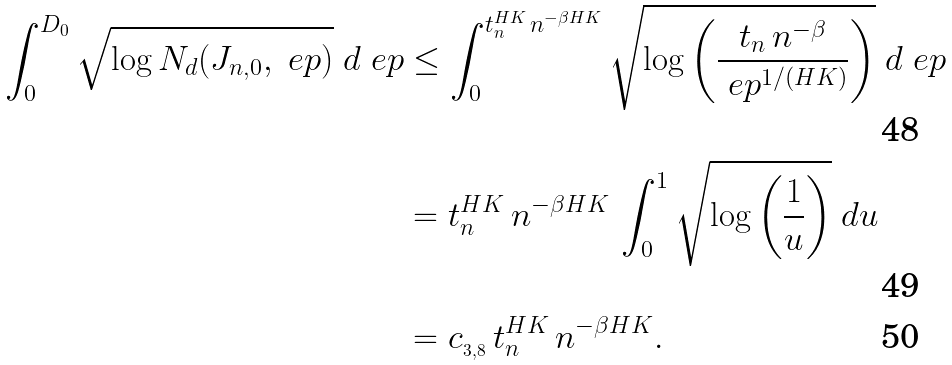Convert formula to latex. <formula><loc_0><loc_0><loc_500><loc_500>\int _ { 0 } ^ { D _ { 0 } } \sqrt { \log N _ { d } ( J _ { n , 0 } , \ e p ) } \ d \ e p & \leq \int _ { 0 } ^ { t _ { n } ^ { H K } \, n ^ { - \beta H K } } \sqrt { \log \left ( \frac { t _ { n } \, n ^ { - \beta } } { \ e p ^ { 1 / ( H K ) } } \right ) } \ d \ e p \\ & = t _ { n } ^ { H K } \, n ^ { - \beta H K } \, \int _ { 0 } ^ { 1 } \sqrt { \log \left ( \frac { 1 } { u } \right ) } \ d u \\ & = c _ { _ { 3 , 8 } } \, t _ { n } ^ { H K } \, n ^ { - \beta H K } .</formula> 